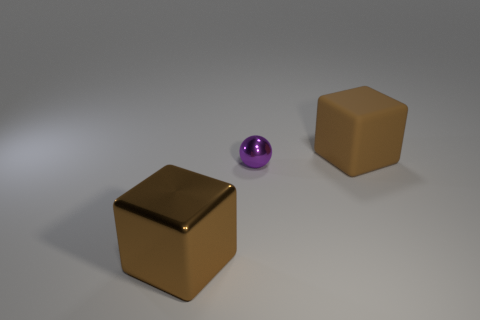What number of other tiny things are the same shape as the brown shiny object?
Give a very brief answer. 0. The brown metal object has what shape?
Ensure brevity in your answer.  Cube. Are there fewer brown metal things than brown cubes?
Your answer should be very brief. Yes. Is there anything else that is the same size as the brown matte block?
Your answer should be very brief. Yes. What is the material of the other thing that is the same shape as the large brown rubber thing?
Give a very brief answer. Metal. Is the number of large rubber blocks greater than the number of purple rubber objects?
Offer a terse response. Yes. What number of other things are there of the same color as the tiny object?
Ensure brevity in your answer.  0. Is the small purple sphere made of the same material as the big block that is behind the purple shiny object?
Offer a terse response. No. How many purple metal things are to the left of the tiny purple metal ball that is in front of the large brown cube behind the purple ball?
Make the answer very short. 0. Is the number of metallic spheres left of the large metal thing less than the number of large matte objects that are to the left of the rubber block?
Provide a succinct answer. No. 